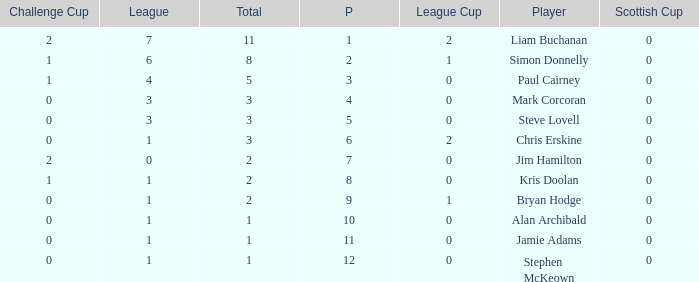What was the lowest number of points scored in the league cup? 0.0. Could you help me parse every detail presented in this table? {'header': ['Challenge Cup', 'League', 'Total', 'P', 'League Cup', 'Player', 'Scottish Cup'], 'rows': [['2', '7', '11', '1', '2', 'Liam Buchanan', '0'], ['1', '6', '8', '2', '1', 'Simon Donnelly', '0'], ['1', '4', '5', '3', '0', 'Paul Cairney', '0'], ['0', '3', '3', '4', '0', 'Mark Corcoran', '0'], ['0', '3', '3', '5', '0', 'Steve Lovell', '0'], ['0', '1', '3', '6', '2', 'Chris Erskine', '0'], ['2', '0', '2', '7', '0', 'Jim Hamilton', '0'], ['1', '1', '2', '8', '0', 'Kris Doolan', '0'], ['0', '1', '2', '9', '1', 'Bryan Hodge', '0'], ['0', '1', '1', '10', '0', 'Alan Archibald', '0'], ['0', '1', '1', '11', '0', 'Jamie Adams', '0'], ['0', '1', '1', '12', '0', 'Stephen McKeown', '0']]} 